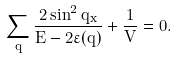<formula> <loc_0><loc_0><loc_500><loc_500>\sum _ { q } \frac { 2 \sin ^ { 2 } { q _ { x } } } { E - 2 \varepsilon ( { q } ) } + \frac { 1 } { V } = 0 .</formula> 